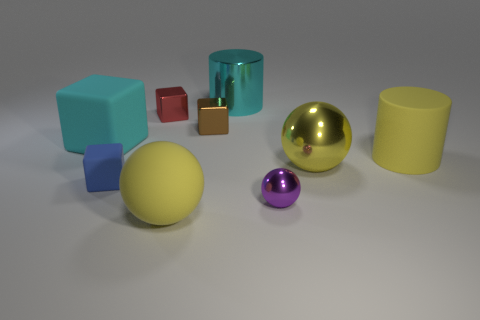Are there any other small red shiny objects of the same shape as the red thing?
Your response must be concise. No. Is the material of the cyan thing to the right of the brown shiny object the same as the red thing on the left side of the small brown shiny block?
Your answer should be compact. Yes. How big is the yellow matte thing that is behind the yellow thing in front of the matte block that is in front of the big rubber cylinder?
Your answer should be compact. Large. There is a brown thing that is the same size as the purple object; what is its material?
Your answer should be very brief. Metal. Are there any shiny blocks that have the same size as the blue rubber cube?
Ensure brevity in your answer.  Yes. Is the shape of the small blue matte object the same as the big cyan rubber object?
Your answer should be very brief. Yes. Are there any tiny brown cubes in front of the matte block that is behind the matte cylinder in front of the cyan metal cylinder?
Offer a very short reply. No. What number of other things are the same color as the big matte cube?
Make the answer very short. 1. Does the metallic ball behind the purple object have the same size as the cyan object that is left of the rubber sphere?
Offer a terse response. Yes. Are there the same number of large spheres left of the blue block and big spheres on the right side of the yellow matte sphere?
Make the answer very short. No. 